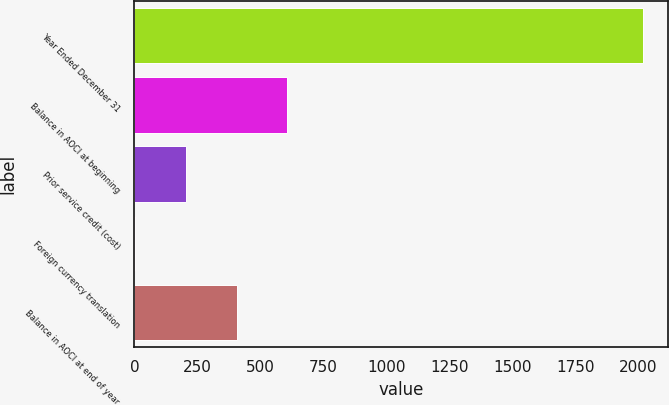<chart> <loc_0><loc_0><loc_500><loc_500><bar_chart><fcel>Year Ended December 31<fcel>Balance in AOCI at beginning<fcel>Prior service credit (cost)<fcel>Foreign currency translation<fcel>Balance in AOCI at end of year<nl><fcel>2018<fcel>607.5<fcel>204.5<fcel>3<fcel>406<nl></chart> 